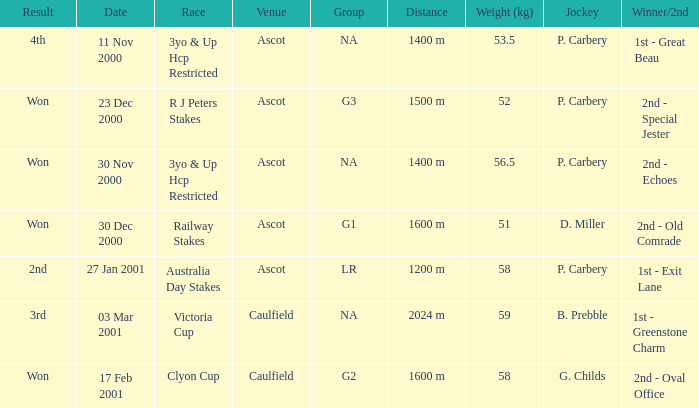What group info is available for the 56.5 kg weight? NA. 